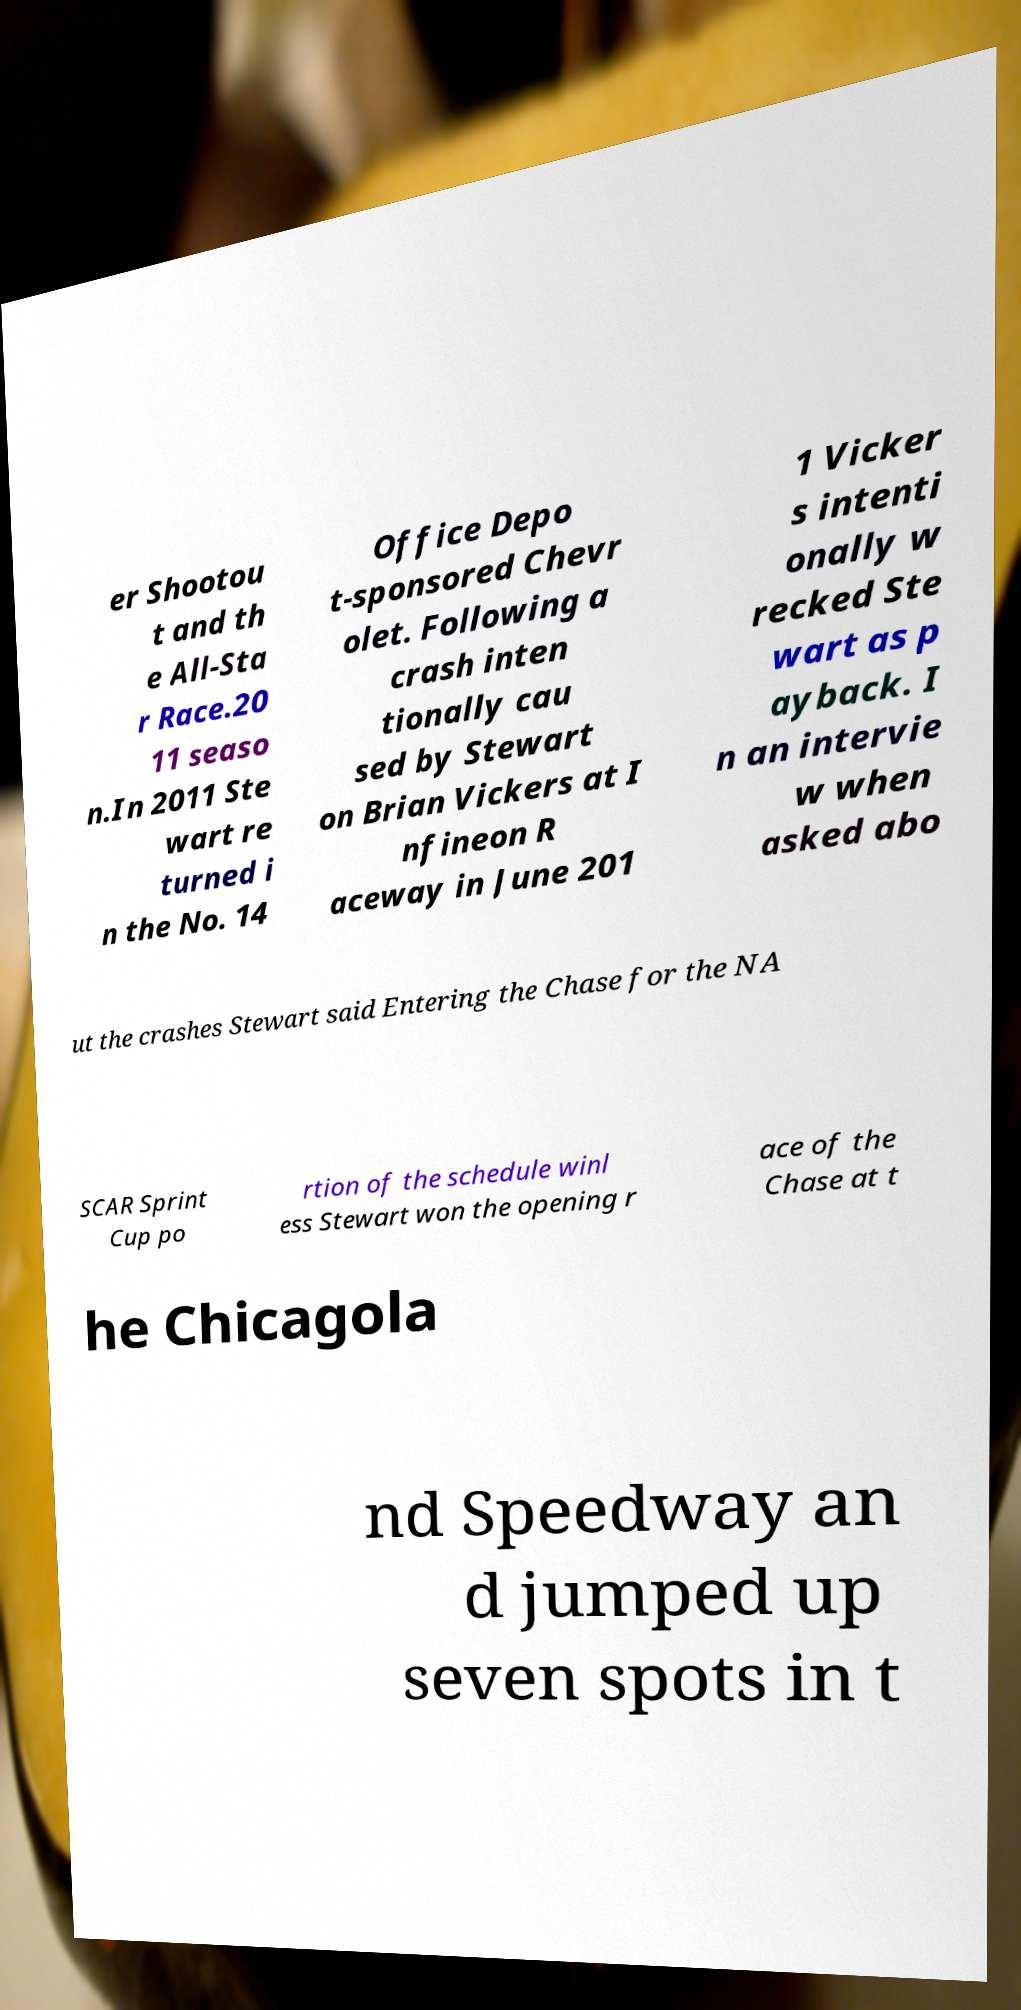Please identify and transcribe the text found in this image. er Shootou t and th e All-Sta r Race.20 11 seaso n.In 2011 Ste wart re turned i n the No. 14 Office Depo t-sponsored Chevr olet. Following a crash inten tionally cau sed by Stewart on Brian Vickers at I nfineon R aceway in June 201 1 Vicker s intenti onally w recked Ste wart as p ayback. I n an intervie w when asked abo ut the crashes Stewart said Entering the Chase for the NA SCAR Sprint Cup po rtion of the schedule winl ess Stewart won the opening r ace of the Chase at t he Chicagola nd Speedway an d jumped up seven spots in t 